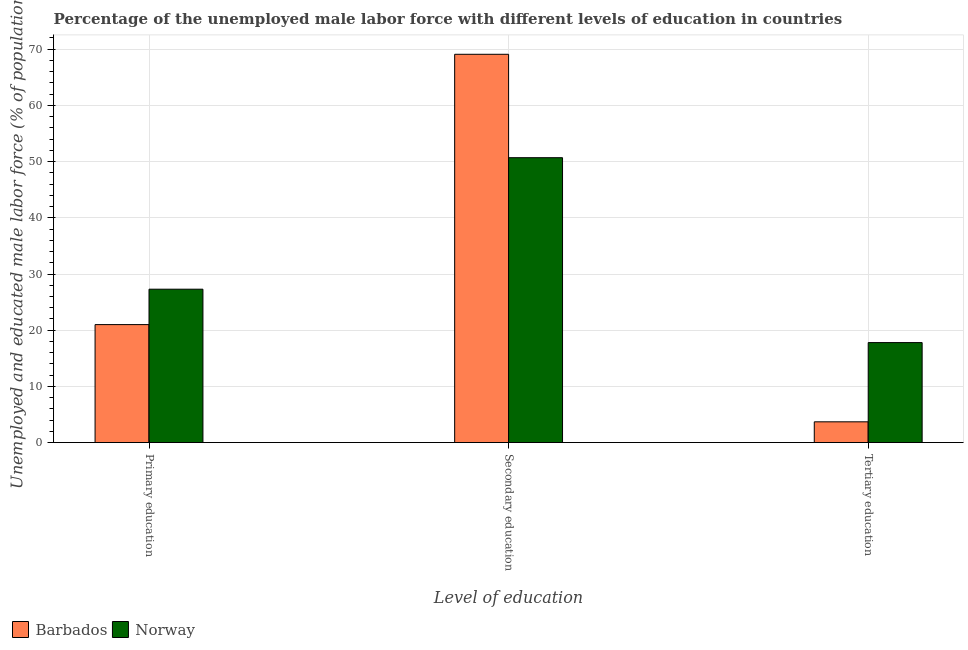How many groups of bars are there?
Make the answer very short. 3. Are the number of bars on each tick of the X-axis equal?
Ensure brevity in your answer.  Yes. How many bars are there on the 2nd tick from the left?
Offer a terse response. 2. What is the label of the 3rd group of bars from the left?
Provide a succinct answer. Tertiary education. What is the percentage of male labor force who received primary education in Norway?
Ensure brevity in your answer.  27.3. Across all countries, what is the maximum percentage of male labor force who received tertiary education?
Make the answer very short. 17.8. Across all countries, what is the minimum percentage of male labor force who received primary education?
Your answer should be very brief. 21. In which country was the percentage of male labor force who received primary education minimum?
Your answer should be very brief. Barbados. What is the total percentage of male labor force who received secondary education in the graph?
Your response must be concise. 119.8. What is the difference between the percentage of male labor force who received secondary education in Barbados and that in Norway?
Your response must be concise. 18.4. What is the difference between the percentage of male labor force who received tertiary education in Barbados and the percentage of male labor force who received secondary education in Norway?
Keep it short and to the point. -47. What is the average percentage of male labor force who received tertiary education per country?
Offer a terse response. 10.75. What is the difference between the percentage of male labor force who received tertiary education and percentage of male labor force who received secondary education in Barbados?
Make the answer very short. -65.4. In how many countries, is the percentage of male labor force who received tertiary education greater than 22 %?
Your response must be concise. 0. What is the ratio of the percentage of male labor force who received primary education in Norway to that in Barbados?
Keep it short and to the point. 1.3. Is the percentage of male labor force who received tertiary education in Norway less than that in Barbados?
Offer a terse response. No. Is the difference between the percentage of male labor force who received secondary education in Norway and Barbados greater than the difference between the percentage of male labor force who received tertiary education in Norway and Barbados?
Your answer should be compact. No. What is the difference between the highest and the second highest percentage of male labor force who received secondary education?
Provide a succinct answer. 18.4. What is the difference between the highest and the lowest percentage of male labor force who received primary education?
Offer a terse response. 6.3. In how many countries, is the percentage of male labor force who received primary education greater than the average percentage of male labor force who received primary education taken over all countries?
Your answer should be very brief. 1. What does the 1st bar from the left in Primary education represents?
Your response must be concise. Barbados. What does the 1st bar from the right in Secondary education represents?
Keep it short and to the point. Norway. Is it the case that in every country, the sum of the percentage of male labor force who received primary education and percentage of male labor force who received secondary education is greater than the percentage of male labor force who received tertiary education?
Your response must be concise. Yes. How many bars are there?
Give a very brief answer. 6. How many countries are there in the graph?
Offer a very short reply. 2. What is the difference between two consecutive major ticks on the Y-axis?
Your answer should be very brief. 10. Where does the legend appear in the graph?
Keep it short and to the point. Bottom left. How are the legend labels stacked?
Ensure brevity in your answer.  Horizontal. What is the title of the graph?
Offer a terse response. Percentage of the unemployed male labor force with different levels of education in countries. Does "Benin" appear as one of the legend labels in the graph?
Your answer should be very brief. No. What is the label or title of the X-axis?
Give a very brief answer. Level of education. What is the label or title of the Y-axis?
Your answer should be compact. Unemployed and educated male labor force (% of population). What is the Unemployed and educated male labor force (% of population) in Barbados in Primary education?
Offer a very short reply. 21. What is the Unemployed and educated male labor force (% of population) of Norway in Primary education?
Your answer should be compact. 27.3. What is the Unemployed and educated male labor force (% of population) of Barbados in Secondary education?
Provide a succinct answer. 69.1. What is the Unemployed and educated male labor force (% of population) of Norway in Secondary education?
Offer a very short reply. 50.7. What is the Unemployed and educated male labor force (% of population) of Barbados in Tertiary education?
Give a very brief answer. 3.7. What is the Unemployed and educated male labor force (% of population) in Norway in Tertiary education?
Make the answer very short. 17.8. Across all Level of education, what is the maximum Unemployed and educated male labor force (% of population) of Barbados?
Your response must be concise. 69.1. Across all Level of education, what is the maximum Unemployed and educated male labor force (% of population) in Norway?
Offer a terse response. 50.7. Across all Level of education, what is the minimum Unemployed and educated male labor force (% of population) in Barbados?
Your answer should be compact. 3.7. Across all Level of education, what is the minimum Unemployed and educated male labor force (% of population) in Norway?
Your response must be concise. 17.8. What is the total Unemployed and educated male labor force (% of population) in Barbados in the graph?
Keep it short and to the point. 93.8. What is the total Unemployed and educated male labor force (% of population) of Norway in the graph?
Offer a very short reply. 95.8. What is the difference between the Unemployed and educated male labor force (% of population) in Barbados in Primary education and that in Secondary education?
Offer a very short reply. -48.1. What is the difference between the Unemployed and educated male labor force (% of population) of Norway in Primary education and that in Secondary education?
Provide a succinct answer. -23.4. What is the difference between the Unemployed and educated male labor force (% of population) of Barbados in Primary education and that in Tertiary education?
Offer a very short reply. 17.3. What is the difference between the Unemployed and educated male labor force (% of population) of Barbados in Secondary education and that in Tertiary education?
Keep it short and to the point. 65.4. What is the difference between the Unemployed and educated male labor force (% of population) of Norway in Secondary education and that in Tertiary education?
Offer a very short reply. 32.9. What is the difference between the Unemployed and educated male labor force (% of population) of Barbados in Primary education and the Unemployed and educated male labor force (% of population) of Norway in Secondary education?
Your response must be concise. -29.7. What is the difference between the Unemployed and educated male labor force (% of population) of Barbados in Secondary education and the Unemployed and educated male labor force (% of population) of Norway in Tertiary education?
Keep it short and to the point. 51.3. What is the average Unemployed and educated male labor force (% of population) in Barbados per Level of education?
Make the answer very short. 31.27. What is the average Unemployed and educated male labor force (% of population) in Norway per Level of education?
Ensure brevity in your answer.  31.93. What is the difference between the Unemployed and educated male labor force (% of population) of Barbados and Unemployed and educated male labor force (% of population) of Norway in Primary education?
Ensure brevity in your answer.  -6.3. What is the difference between the Unemployed and educated male labor force (% of population) in Barbados and Unemployed and educated male labor force (% of population) in Norway in Secondary education?
Keep it short and to the point. 18.4. What is the difference between the Unemployed and educated male labor force (% of population) of Barbados and Unemployed and educated male labor force (% of population) of Norway in Tertiary education?
Offer a very short reply. -14.1. What is the ratio of the Unemployed and educated male labor force (% of population) of Barbados in Primary education to that in Secondary education?
Keep it short and to the point. 0.3. What is the ratio of the Unemployed and educated male labor force (% of population) in Norway in Primary education to that in Secondary education?
Make the answer very short. 0.54. What is the ratio of the Unemployed and educated male labor force (% of population) of Barbados in Primary education to that in Tertiary education?
Give a very brief answer. 5.68. What is the ratio of the Unemployed and educated male labor force (% of population) in Norway in Primary education to that in Tertiary education?
Make the answer very short. 1.53. What is the ratio of the Unemployed and educated male labor force (% of population) in Barbados in Secondary education to that in Tertiary education?
Offer a very short reply. 18.68. What is the ratio of the Unemployed and educated male labor force (% of population) of Norway in Secondary education to that in Tertiary education?
Your response must be concise. 2.85. What is the difference between the highest and the second highest Unemployed and educated male labor force (% of population) of Barbados?
Make the answer very short. 48.1. What is the difference between the highest and the second highest Unemployed and educated male labor force (% of population) in Norway?
Ensure brevity in your answer.  23.4. What is the difference between the highest and the lowest Unemployed and educated male labor force (% of population) of Barbados?
Ensure brevity in your answer.  65.4. What is the difference between the highest and the lowest Unemployed and educated male labor force (% of population) of Norway?
Keep it short and to the point. 32.9. 